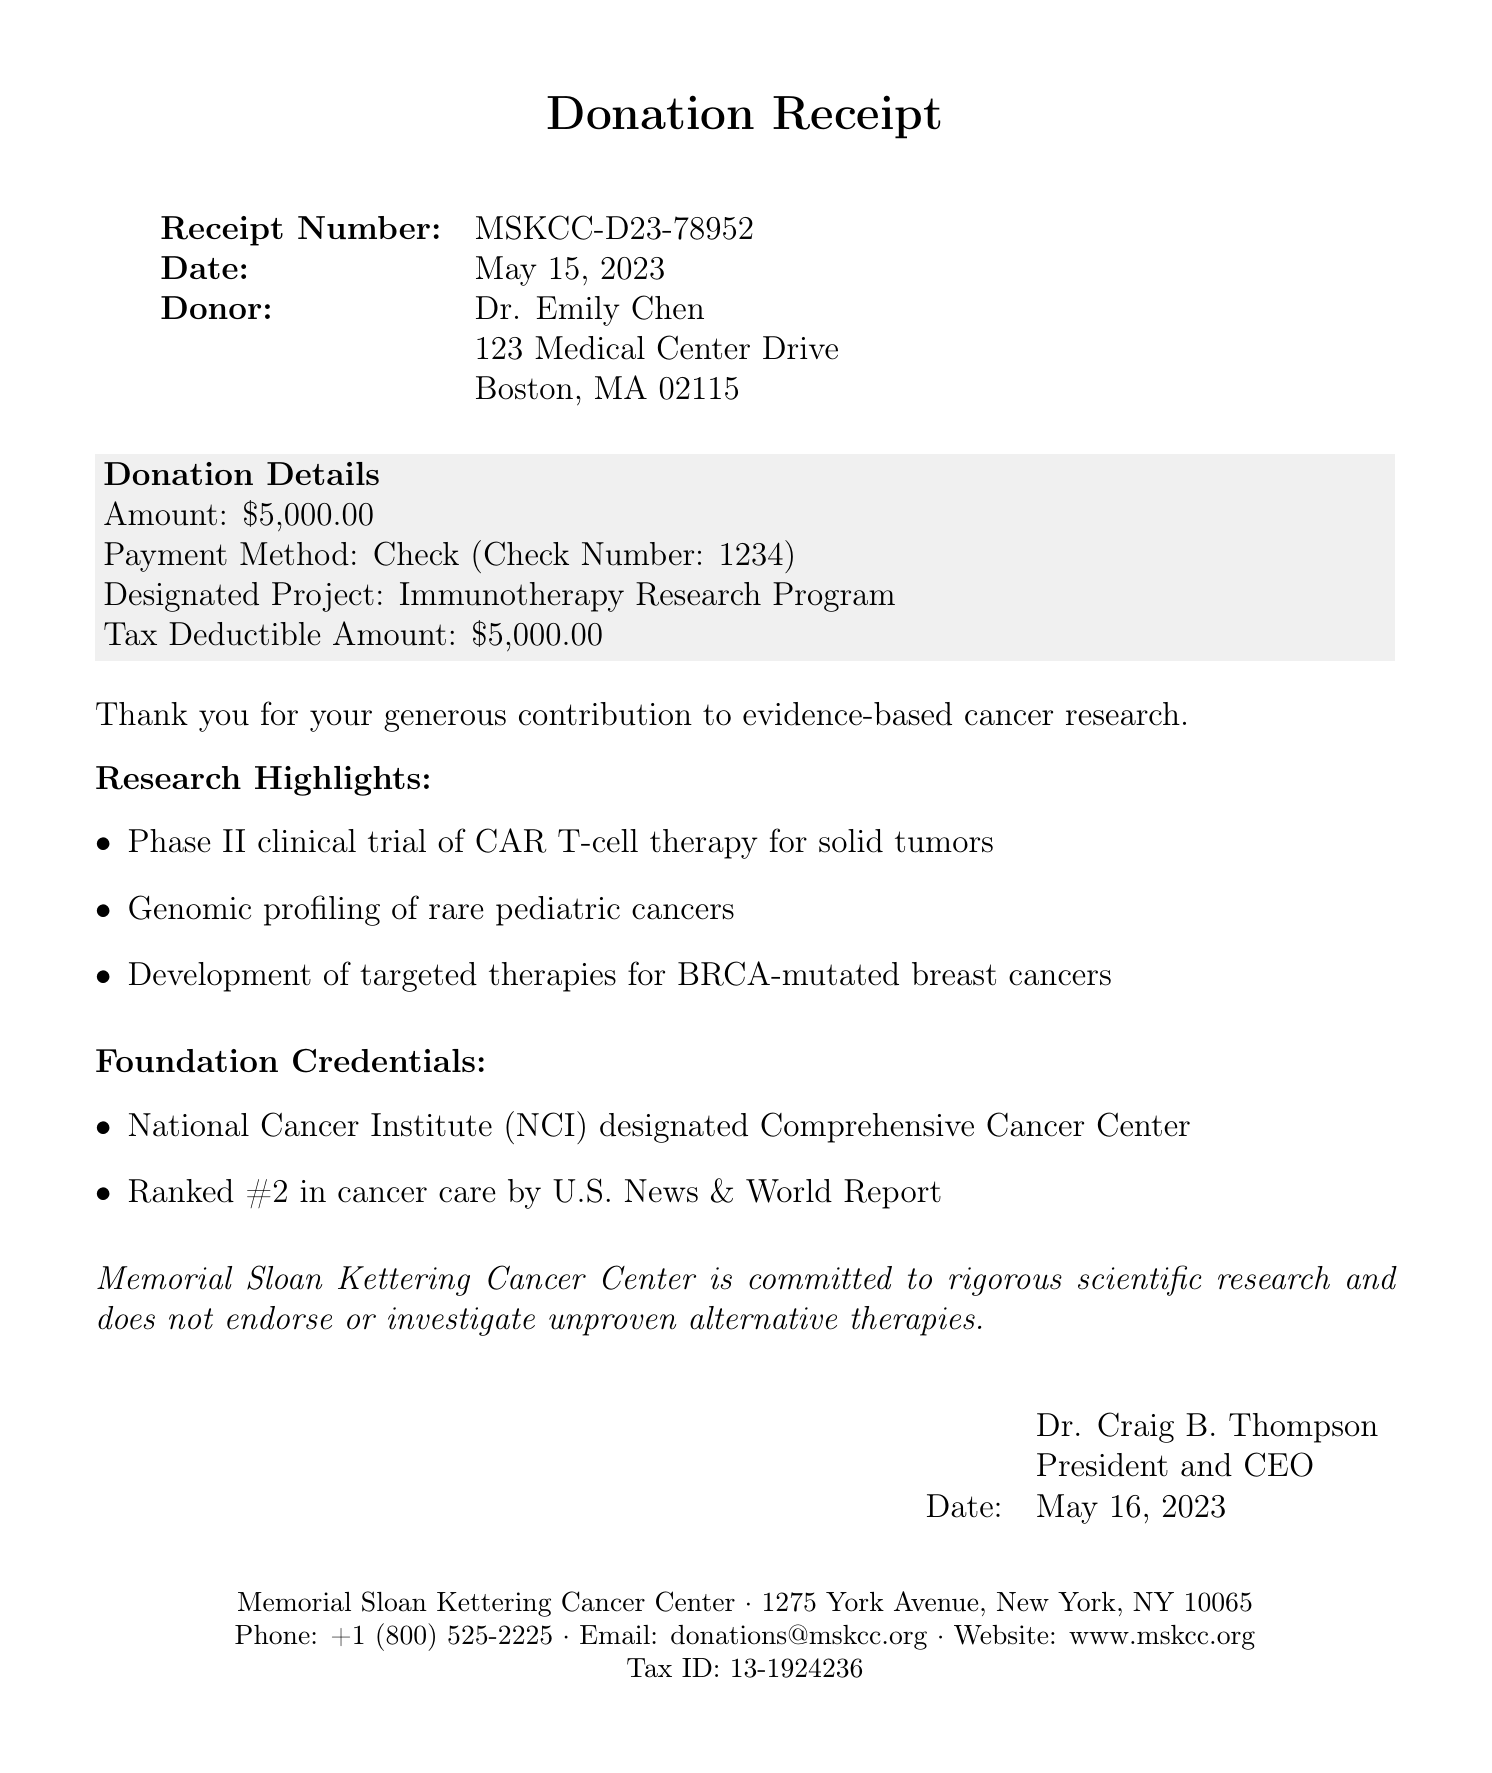What is the receipt number? The receipt number is a unique identifier for the donation, shown at the start of the document.
Answer: MSKCC-D23-78952 What is the donation amount? The donation amount is provided in the donation details section, specifying how much was donated.
Answer: $5,000.00 Who is the donor? The donor's name is mentioned prominently at the top of the document to credit the giver of the donation.
Answer: Dr. Emily Chen What project is the donation designated for? The designated project is stated clearly in the donation details to specify how the funds will be used.
Answer: Immunotherapy Research Program When was the donation made? The donation date indicates when the donor made their contribution to the foundation, found in the initial details of the document.
Answer: May 15, 2023 What is the tax ID of the foundation? The tax ID is included at the bottom of the document, which is important for tax-deductible purposes.
Answer: 13-1924236 What is the foundation's ranking according to U.S. News? The ranking provides an external verification of the foundation's reputation and is noted under foundation credentials.
Answer: #2 What is the purpose of the disclaimer? The disclaimer serves to clarify the foundation's commitment to evidence-based practices, specifically in cancer research.
Answer: To emphasize commitment to scientific research Who signed the document? The signature section indicates who authorized the receipt, providing credibility and an official touch to the document.
Answer: Dr. Craig B. Thompson What is the foundation's contact phone number? The phone number is provided in the contact information section for inquiries related to donations.
Answer: +1 (800) 525-2225 